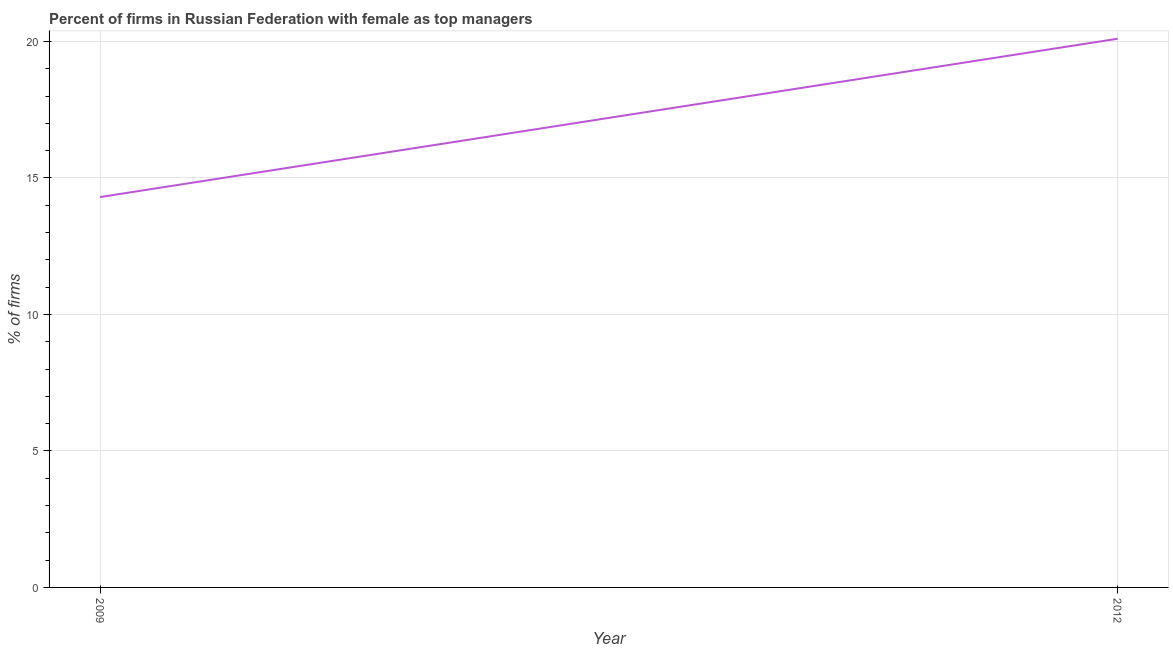What is the percentage of firms with female as top manager in 2012?
Ensure brevity in your answer.  20.1. Across all years, what is the maximum percentage of firms with female as top manager?
Keep it short and to the point. 20.1. What is the sum of the percentage of firms with female as top manager?
Make the answer very short. 34.4. What is the difference between the percentage of firms with female as top manager in 2009 and 2012?
Offer a very short reply. -5.8. What is the average percentage of firms with female as top manager per year?
Your answer should be compact. 17.2. What is the median percentage of firms with female as top manager?
Provide a succinct answer. 17.2. In how many years, is the percentage of firms with female as top manager greater than 1 %?
Make the answer very short. 2. What is the ratio of the percentage of firms with female as top manager in 2009 to that in 2012?
Make the answer very short. 0.71. How many lines are there?
Give a very brief answer. 1. How many years are there in the graph?
Your answer should be compact. 2. What is the difference between two consecutive major ticks on the Y-axis?
Offer a terse response. 5. Are the values on the major ticks of Y-axis written in scientific E-notation?
Provide a short and direct response. No. Does the graph contain any zero values?
Offer a terse response. No. Does the graph contain grids?
Ensure brevity in your answer.  Yes. What is the title of the graph?
Your response must be concise. Percent of firms in Russian Federation with female as top managers. What is the label or title of the Y-axis?
Your response must be concise. % of firms. What is the % of firms of 2009?
Offer a terse response. 14.3. What is the % of firms in 2012?
Your answer should be compact. 20.1. What is the difference between the % of firms in 2009 and 2012?
Your answer should be compact. -5.8. What is the ratio of the % of firms in 2009 to that in 2012?
Keep it short and to the point. 0.71. 